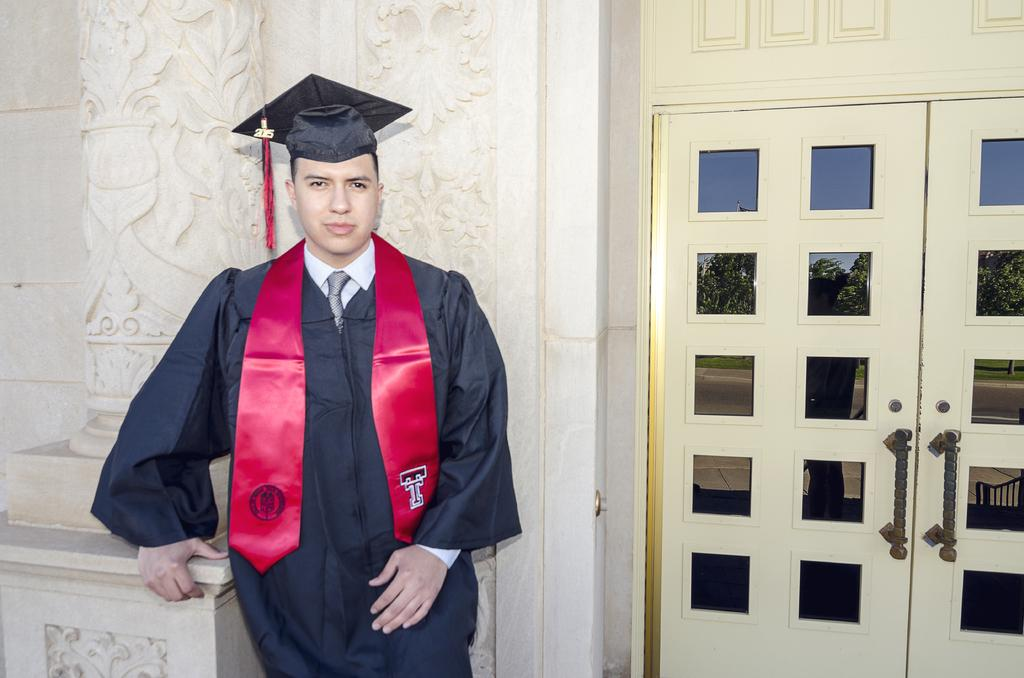Who is present in the image? There is a person in the image. What is the person wearing? The person is wearing a graduation dress. What can be seen in the background of the image? There is a sculpture wall in the background of the image. Where is the door located in the image? The door is in the right corner of the image. What type of pencil can be seen in the person's hand in the image? There is no pencil present in the person's hand or anywhere in the image. 